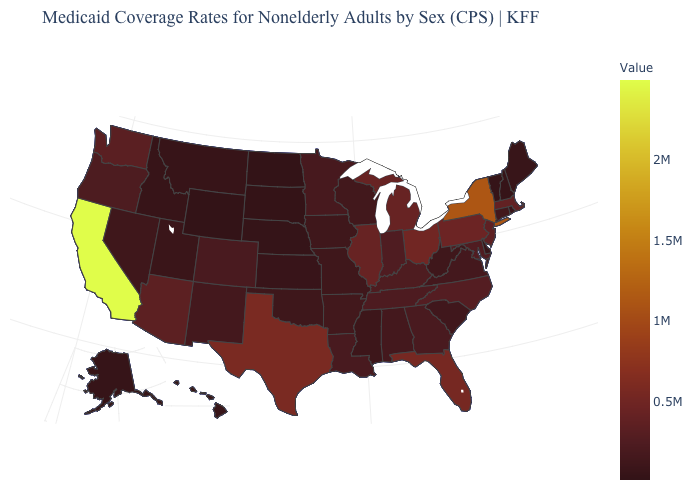Does Kentucky have a higher value than Ohio?
Write a very short answer. No. Among the states that border Pennsylvania , which have the highest value?
Keep it brief. New York. Which states have the highest value in the USA?
Keep it brief. California. 